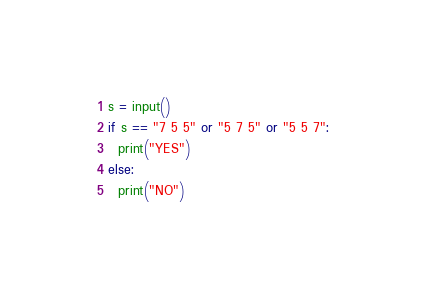<code> <loc_0><loc_0><loc_500><loc_500><_Python_>s = input()
if s == "7 5 5" or "5 7 5" or "5 5 7":
  print("YES")
else:
  print("NO")</code> 